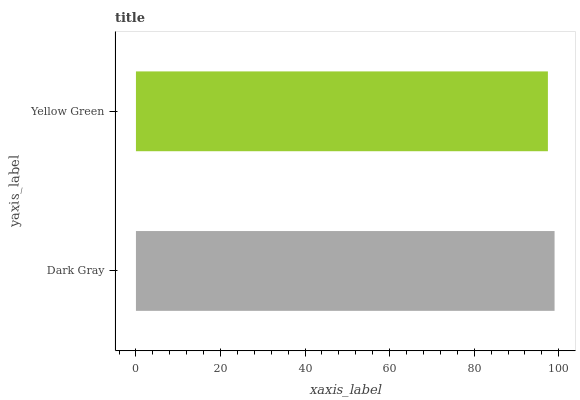Is Yellow Green the minimum?
Answer yes or no. Yes. Is Dark Gray the maximum?
Answer yes or no. Yes. Is Yellow Green the maximum?
Answer yes or no. No. Is Dark Gray greater than Yellow Green?
Answer yes or no. Yes. Is Yellow Green less than Dark Gray?
Answer yes or no. Yes. Is Yellow Green greater than Dark Gray?
Answer yes or no. No. Is Dark Gray less than Yellow Green?
Answer yes or no. No. Is Dark Gray the high median?
Answer yes or no. Yes. Is Yellow Green the low median?
Answer yes or no. Yes. Is Yellow Green the high median?
Answer yes or no. No. Is Dark Gray the low median?
Answer yes or no. No. 